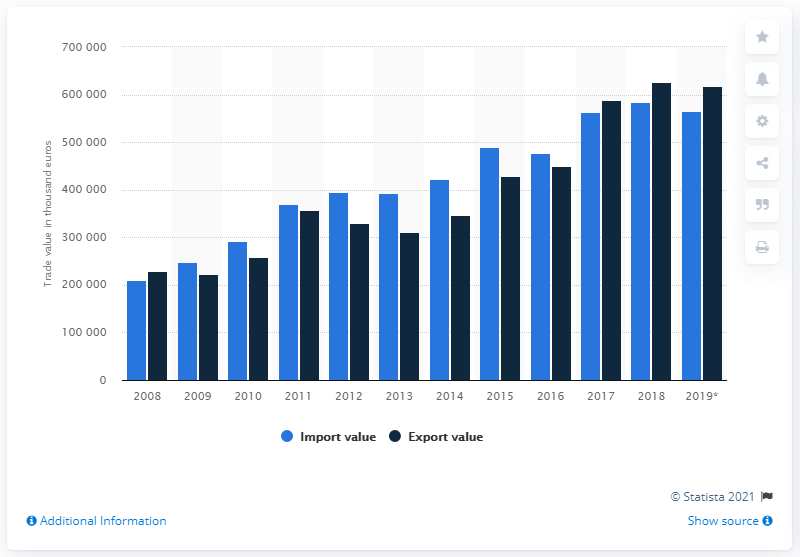Point out several critical features in this image. The value of roasted coffee in the Netherlands in 2019 was 617,732 units. 